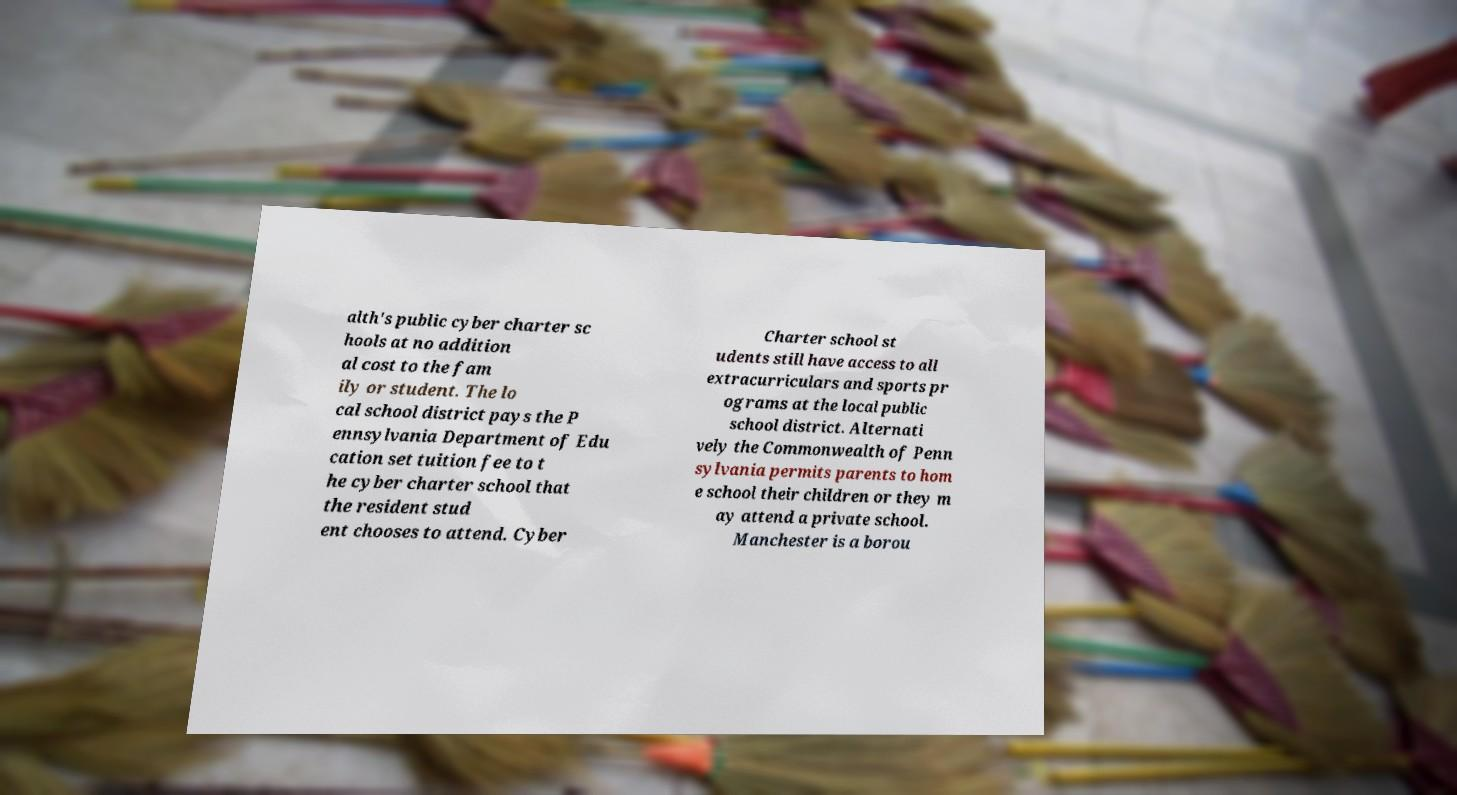Can you accurately transcribe the text from the provided image for me? alth's public cyber charter sc hools at no addition al cost to the fam ily or student. The lo cal school district pays the P ennsylvania Department of Edu cation set tuition fee to t he cyber charter school that the resident stud ent chooses to attend. Cyber Charter school st udents still have access to all extracurriculars and sports pr ograms at the local public school district. Alternati vely the Commonwealth of Penn sylvania permits parents to hom e school their children or they m ay attend a private school. Manchester is a borou 